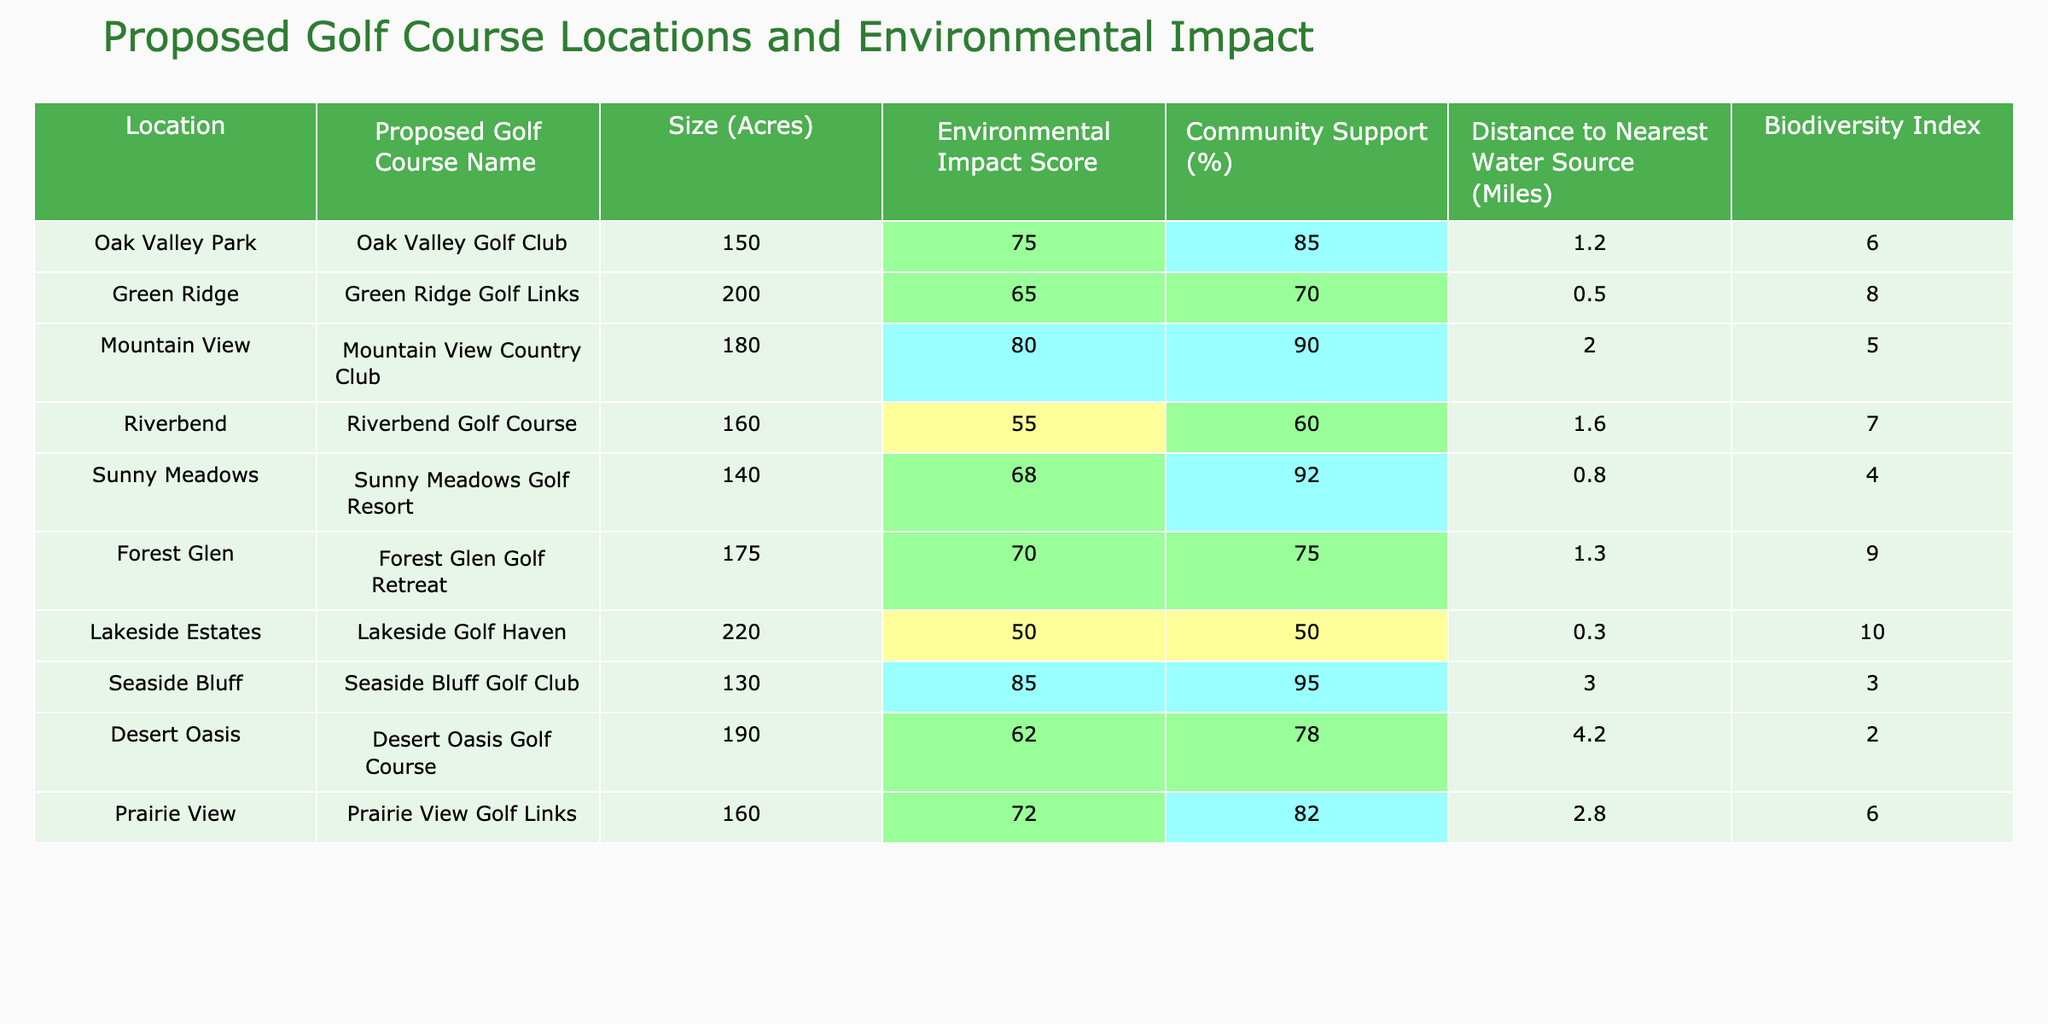What is the Environmental Impact Score of Sunny Meadows Golf Resort? The Environmental Impact Score is listed in the table under "Environmental Impact Score" for Sunny Meadows Golf Resort, which shows a score of 68.
Answer: 68 Which golf course has the highest Community Support percentage? By looking at the "Community Support (%)" column, Mountain View Country Club has the highest percentage at 90.
Answer: 90 What is the average size of the proposed golf courses in acres? The sizes of the proposed golf courses are 150, 200, 180, 160, 140, 175, 220, 130, 190, and 160 acres. They sum up to 1,675 acres. Dividing by 10 gives an average size of 167.5 acres.
Answer: 167.5 Is the Environmental Impact Score for Lakeside Golf Haven below 60? The Environmental Impact Score for Lakeside Golf Haven is 50, which is below 60.
Answer: Yes Which golf course is furthest away from a water source? The Distance to Nearest Water Source column shows that Desert Oasis Golf Course is furthest away at 4.2 miles.
Answer: 4.2 miles What is the difference between the Community Support percentages of Riverbend and Prairie View? Riverbend has 60% Community Support, while Prairie View has 82%. The difference is 82 - 60 = 22%.
Answer: 22% How many proposed golf courses have an Environmental Impact Score of 70 or above? The scores of proposed golf courses are 75, 65, 80, 55, 68, 70, 50, 85, 62, and 72. The scores above 70 are Oak Valley Golf Club (75), Mountain View Country Club (80), and Seaside Bluff Golf Club (85), making a total of 4 courses.
Answer: 4 Which golf course has the lowest Biodiversity Index? The Biodiversity Index for each golf course shows that Sunny Meadows Golf Resort has the lowest score of 4.
Answer: 4 What is the sum of the Environmental Impact Scores for all proposed golf courses? The Environmental Impact Scores are 75, 65, 80, 55, 68, 70, 50, 85, 62, and 72. Summing these gives 75 + 65 + 80 + 55 + 68 + 70 + 50 + 85 + 62 + 72 =  792.
Answer: 792 Is there a golf course with both high Environmental Impact Score and high Community Support? By comparing both columns, Mountain View Country Club has an Environmental Impact Score of 80 and Community Support of 90, which are both high.
Answer: Yes 